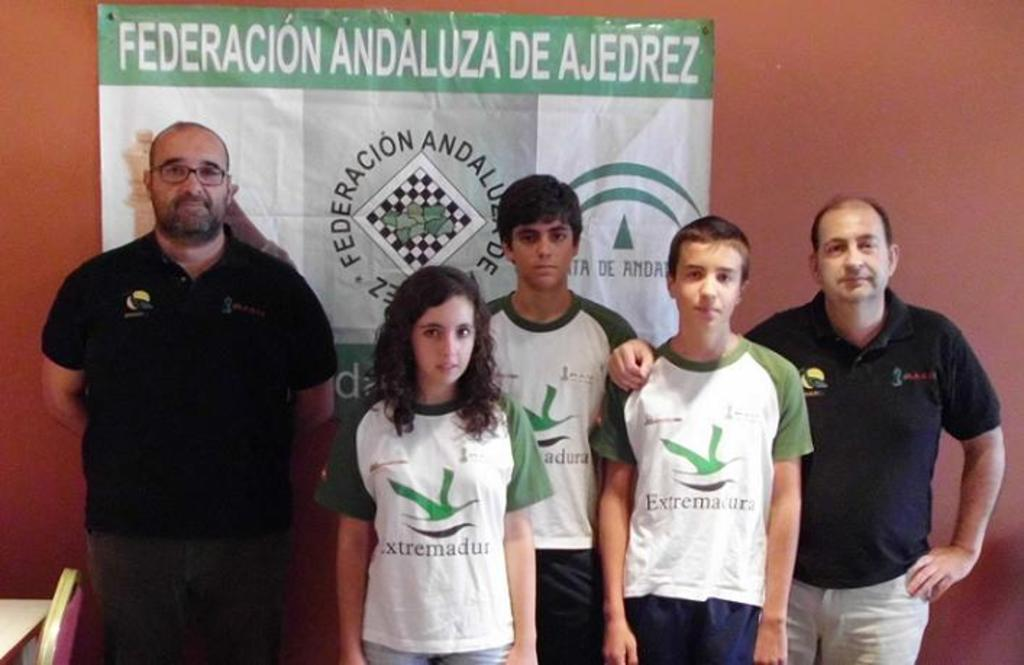<image>
Provide a brief description of the given image. two men with three kids standing in front of a wall poster saying FEDERACION ANDALUZA DE AJEDREZ 